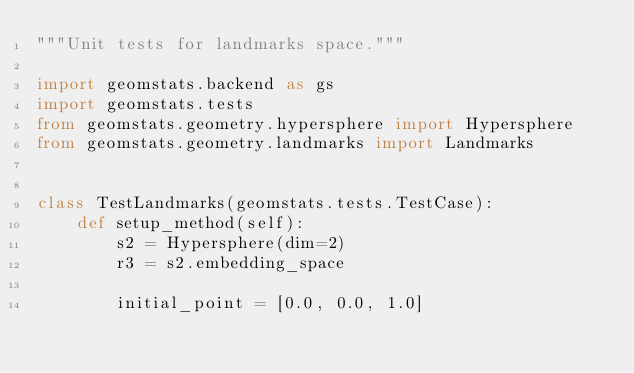Convert code to text. <code><loc_0><loc_0><loc_500><loc_500><_Python_>"""Unit tests for landmarks space."""

import geomstats.backend as gs
import geomstats.tests
from geomstats.geometry.hypersphere import Hypersphere
from geomstats.geometry.landmarks import Landmarks


class TestLandmarks(geomstats.tests.TestCase):
    def setup_method(self):
        s2 = Hypersphere(dim=2)
        r3 = s2.embedding_space

        initial_point = [0.0, 0.0, 1.0]</code> 